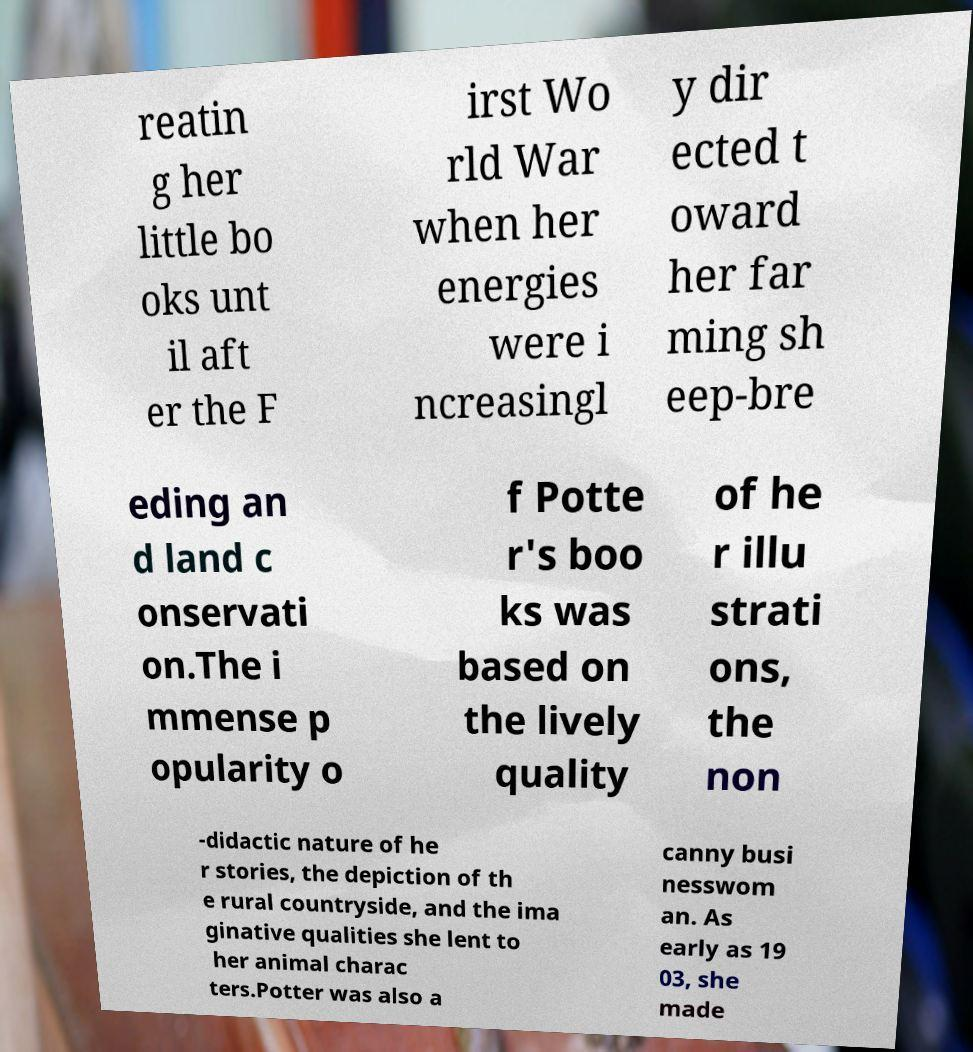Please read and relay the text visible in this image. What does it say? reatin g her little bo oks unt il aft er the F irst Wo rld War when her energies were i ncreasingl y dir ected t oward her far ming sh eep-bre eding an d land c onservati on.The i mmense p opularity o f Potte r's boo ks was based on the lively quality of he r illu strati ons, the non -didactic nature of he r stories, the depiction of th e rural countryside, and the ima ginative qualities she lent to her animal charac ters.Potter was also a canny busi nesswom an. As early as 19 03, she made 